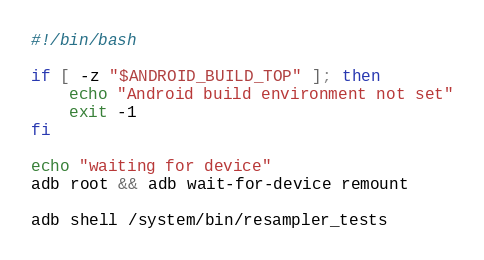Convert code to text. <code><loc_0><loc_0><loc_500><loc_500><_Bash_>#!/bin/bash

if [ -z "$ANDROID_BUILD_TOP" ]; then
    echo "Android build environment not set"
    exit -1
fi

echo "waiting for device"
adb root && adb wait-for-device remount

adb shell /system/bin/resampler_tests
</code> 